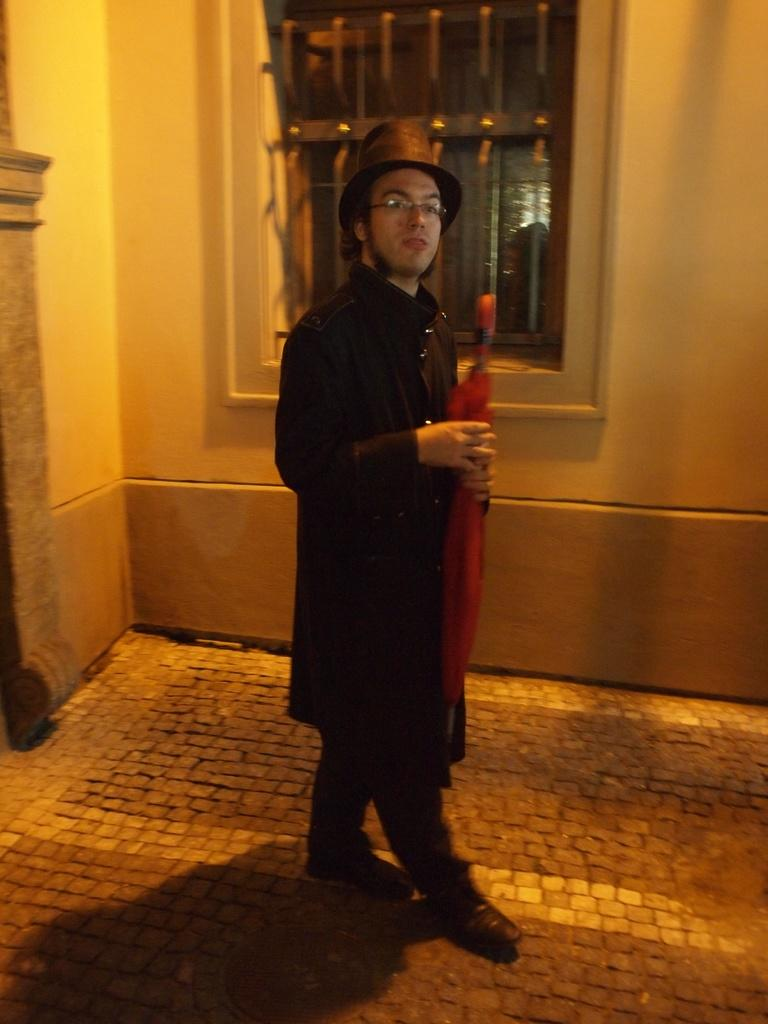What is the main subject of the image? There is a man standing in the image. Can you describe the man's attire? The man is wearing clothes, a hat, and spectacles. What is the man holding in his hand? The man is holding an object in his hand, but the specific object is not mentioned in the facts. What type of floor is visible in the image? The facts do not specify the type of floor visible in the image. What architectural features can be seen in the image? There is a wall and a window visible in the image. Can you tell me how many geese are visible through the window in the image? There is no mention of geese or a window view in the provided facts, so it is impossible to answer this question based on the information given. 